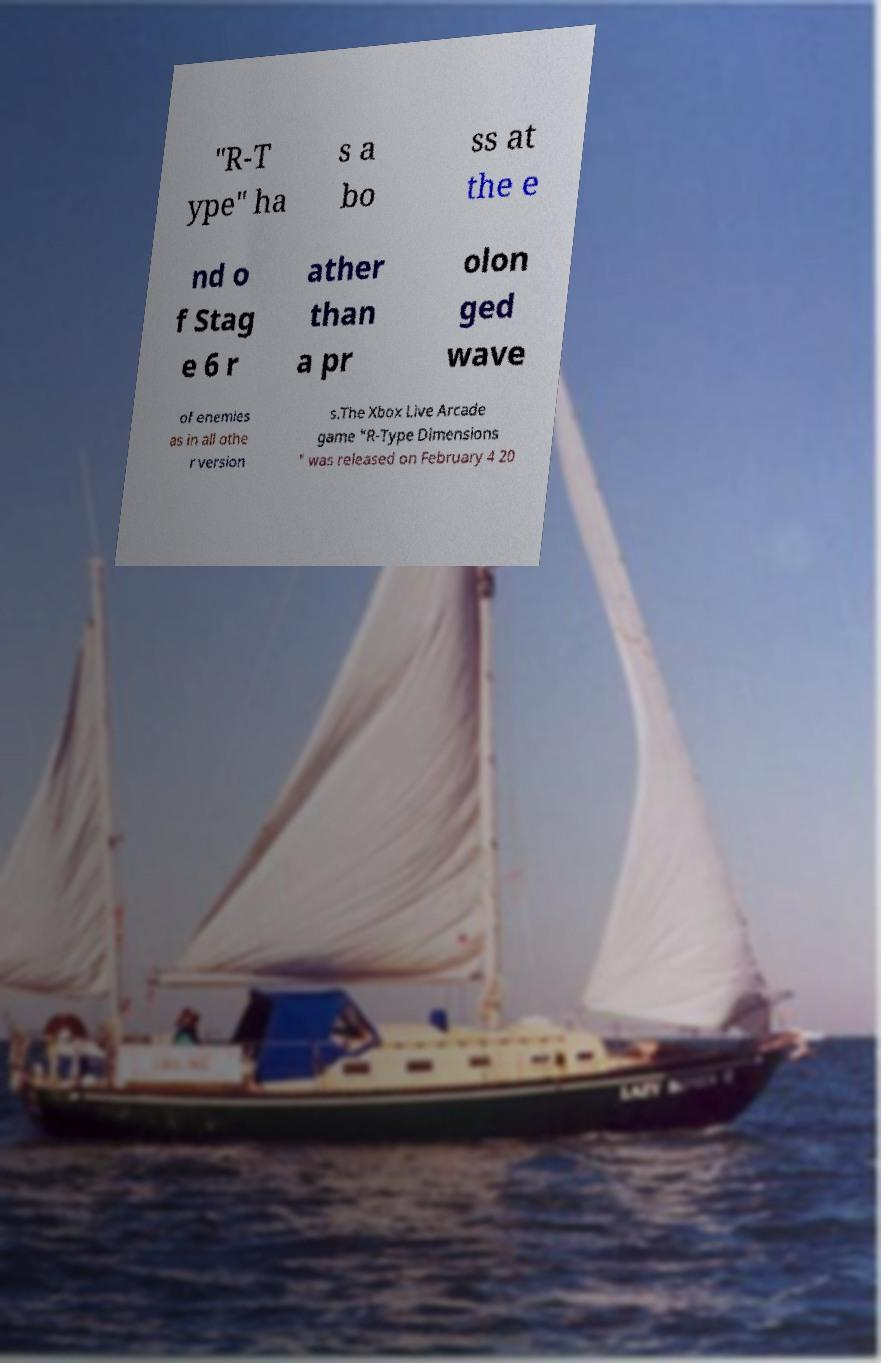Can you read and provide the text displayed in the image?This photo seems to have some interesting text. Can you extract and type it out for me? "R-T ype" ha s a bo ss at the e nd o f Stag e 6 r ather than a pr olon ged wave of enemies as in all othe r version s.The Xbox Live Arcade game "R-Type Dimensions " was released on February 4 20 